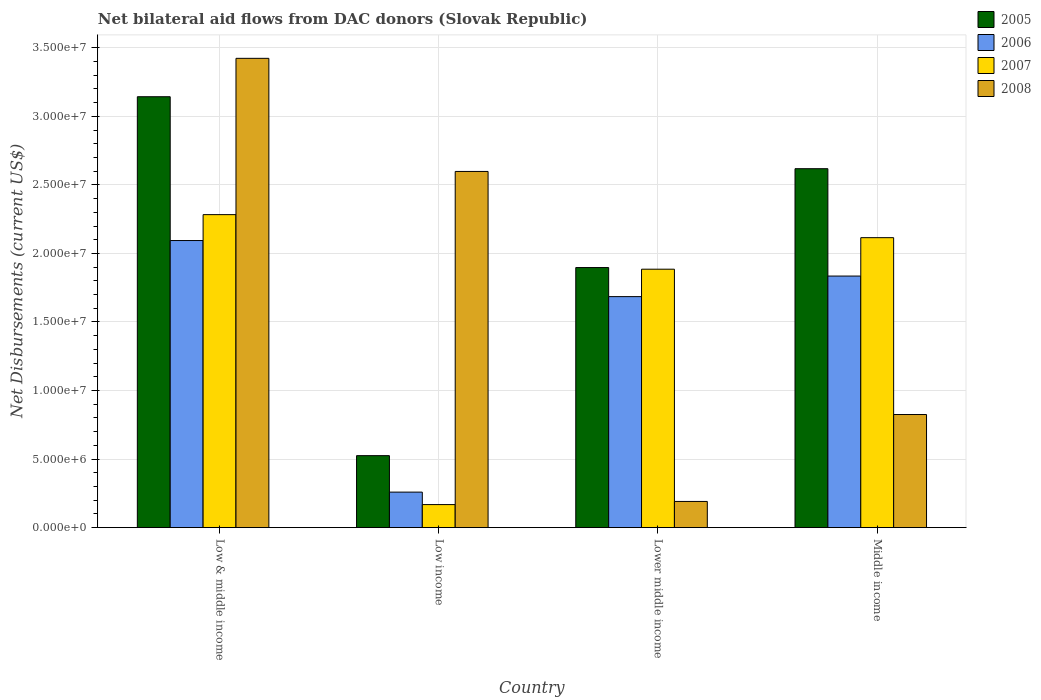How many different coloured bars are there?
Provide a short and direct response. 4. Are the number of bars on each tick of the X-axis equal?
Your answer should be very brief. Yes. How many bars are there on the 1st tick from the right?
Your response must be concise. 4. What is the label of the 3rd group of bars from the left?
Make the answer very short. Lower middle income. What is the net bilateral aid flows in 2007 in Low & middle income?
Give a very brief answer. 2.28e+07. Across all countries, what is the maximum net bilateral aid flows in 2006?
Your answer should be compact. 2.09e+07. Across all countries, what is the minimum net bilateral aid flows in 2006?
Your answer should be compact. 2.59e+06. In which country was the net bilateral aid flows in 2005 maximum?
Make the answer very short. Low & middle income. What is the total net bilateral aid flows in 2005 in the graph?
Offer a terse response. 8.18e+07. What is the difference between the net bilateral aid flows in 2006 in Lower middle income and that in Middle income?
Give a very brief answer. -1.50e+06. What is the difference between the net bilateral aid flows in 2007 in Low & middle income and the net bilateral aid flows in 2005 in Lower middle income?
Give a very brief answer. 3.86e+06. What is the average net bilateral aid flows in 2005 per country?
Offer a very short reply. 2.05e+07. What is the difference between the net bilateral aid flows of/in 2006 and net bilateral aid flows of/in 2005 in Middle income?
Ensure brevity in your answer.  -7.83e+06. In how many countries, is the net bilateral aid flows in 2005 greater than 9000000 US$?
Provide a short and direct response. 3. What is the ratio of the net bilateral aid flows in 2008 in Low income to that in Lower middle income?
Your answer should be compact. 13.6. Is the net bilateral aid flows in 2006 in Low & middle income less than that in Low income?
Offer a terse response. No. What is the difference between the highest and the second highest net bilateral aid flows in 2005?
Provide a short and direct response. 1.25e+07. What is the difference between the highest and the lowest net bilateral aid flows in 2008?
Your answer should be very brief. 3.23e+07. In how many countries, is the net bilateral aid flows in 2006 greater than the average net bilateral aid flows in 2006 taken over all countries?
Your answer should be compact. 3. Is the sum of the net bilateral aid flows in 2005 in Low income and Middle income greater than the maximum net bilateral aid flows in 2006 across all countries?
Give a very brief answer. Yes. Are the values on the major ticks of Y-axis written in scientific E-notation?
Offer a very short reply. Yes. Where does the legend appear in the graph?
Offer a terse response. Top right. How many legend labels are there?
Your response must be concise. 4. What is the title of the graph?
Your response must be concise. Net bilateral aid flows from DAC donors (Slovak Republic). What is the label or title of the X-axis?
Provide a short and direct response. Country. What is the label or title of the Y-axis?
Provide a succinct answer. Net Disbursements (current US$). What is the Net Disbursements (current US$) of 2005 in Low & middle income?
Offer a very short reply. 3.14e+07. What is the Net Disbursements (current US$) in 2006 in Low & middle income?
Provide a succinct answer. 2.09e+07. What is the Net Disbursements (current US$) in 2007 in Low & middle income?
Your answer should be compact. 2.28e+07. What is the Net Disbursements (current US$) of 2008 in Low & middle income?
Offer a terse response. 3.42e+07. What is the Net Disbursements (current US$) in 2005 in Low income?
Your answer should be compact. 5.25e+06. What is the Net Disbursements (current US$) in 2006 in Low income?
Offer a very short reply. 2.59e+06. What is the Net Disbursements (current US$) of 2007 in Low income?
Provide a succinct answer. 1.68e+06. What is the Net Disbursements (current US$) in 2008 in Low income?
Offer a very short reply. 2.60e+07. What is the Net Disbursements (current US$) in 2005 in Lower middle income?
Provide a short and direct response. 1.90e+07. What is the Net Disbursements (current US$) in 2006 in Lower middle income?
Your answer should be very brief. 1.68e+07. What is the Net Disbursements (current US$) in 2007 in Lower middle income?
Make the answer very short. 1.88e+07. What is the Net Disbursements (current US$) of 2008 in Lower middle income?
Ensure brevity in your answer.  1.91e+06. What is the Net Disbursements (current US$) in 2005 in Middle income?
Keep it short and to the point. 2.62e+07. What is the Net Disbursements (current US$) in 2006 in Middle income?
Keep it short and to the point. 1.84e+07. What is the Net Disbursements (current US$) in 2007 in Middle income?
Keep it short and to the point. 2.12e+07. What is the Net Disbursements (current US$) of 2008 in Middle income?
Your answer should be compact. 8.25e+06. Across all countries, what is the maximum Net Disbursements (current US$) of 2005?
Give a very brief answer. 3.14e+07. Across all countries, what is the maximum Net Disbursements (current US$) of 2006?
Your response must be concise. 2.09e+07. Across all countries, what is the maximum Net Disbursements (current US$) of 2007?
Offer a very short reply. 2.28e+07. Across all countries, what is the maximum Net Disbursements (current US$) of 2008?
Ensure brevity in your answer.  3.42e+07. Across all countries, what is the minimum Net Disbursements (current US$) of 2005?
Provide a succinct answer. 5.25e+06. Across all countries, what is the minimum Net Disbursements (current US$) in 2006?
Keep it short and to the point. 2.59e+06. Across all countries, what is the minimum Net Disbursements (current US$) of 2007?
Offer a very short reply. 1.68e+06. Across all countries, what is the minimum Net Disbursements (current US$) in 2008?
Your answer should be compact. 1.91e+06. What is the total Net Disbursements (current US$) in 2005 in the graph?
Offer a very short reply. 8.18e+07. What is the total Net Disbursements (current US$) in 2006 in the graph?
Keep it short and to the point. 5.87e+07. What is the total Net Disbursements (current US$) of 2007 in the graph?
Provide a short and direct response. 6.45e+07. What is the total Net Disbursements (current US$) in 2008 in the graph?
Provide a short and direct response. 7.04e+07. What is the difference between the Net Disbursements (current US$) in 2005 in Low & middle income and that in Low income?
Ensure brevity in your answer.  2.62e+07. What is the difference between the Net Disbursements (current US$) in 2006 in Low & middle income and that in Low income?
Offer a very short reply. 1.84e+07. What is the difference between the Net Disbursements (current US$) of 2007 in Low & middle income and that in Low income?
Ensure brevity in your answer.  2.12e+07. What is the difference between the Net Disbursements (current US$) of 2008 in Low & middle income and that in Low income?
Give a very brief answer. 8.25e+06. What is the difference between the Net Disbursements (current US$) in 2005 in Low & middle income and that in Lower middle income?
Make the answer very short. 1.25e+07. What is the difference between the Net Disbursements (current US$) of 2006 in Low & middle income and that in Lower middle income?
Your answer should be compact. 4.09e+06. What is the difference between the Net Disbursements (current US$) of 2007 in Low & middle income and that in Lower middle income?
Give a very brief answer. 3.98e+06. What is the difference between the Net Disbursements (current US$) of 2008 in Low & middle income and that in Lower middle income?
Keep it short and to the point. 3.23e+07. What is the difference between the Net Disbursements (current US$) of 2005 in Low & middle income and that in Middle income?
Your answer should be compact. 5.25e+06. What is the difference between the Net Disbursements (current US$) of 2006 in Low & middle income and that in Middle income?
Offer a very short reply. 2.59e+06. What is the difference between the Net Disbursements (current US$) in 2007 in Low & middle income and that in Middle income?
Ensure brevity in your answer.  1.68e+06. What is the difference between the Net Disbursements (current US$) of 2008 in Low & middle income and that in Middle income?
Your response must be concise. 2.60e+07. What is the difference between the Net Disbursements (current US$) in 2005 in Low income and that in Lower middle income?
Keep it short and to the point. -1.37e+07. What is the difference between the Net Disbursements (current US$) of 2006 in Low income and that in Lower middle income?
Provide a succinct answer. -1.43e+07. What is the difference between the Net Disbursements (current US$) in 2007 in Low income and that in Lower middle income?
Your answer should be compact. -1.72e+07. What is the difference between the Net Disbursements (current US$) of 2008 in Low income and that in Lower middle income?
Provide a short and direct response. 2.41e+07. What is the difference between the Net Disbursements (current US$) of 2005 in Low income and that in Middle income?
Offer a terse response. -2.09e+07. What is the difference between the Net Disbursements (current US$) in 2006 in Low income and that in Middle income?
Give a very brief answer. -1.58e+07. What is the difference between the Net Disbursements (current US$) of 2007 in Low income and that in Middle income?
Make the answer very short. -1.95e+07. What is the difference between the Net Disbursements (current US$) of 2008 in Low income and that in Middle income?
Ensure brevity in your answer.  1.77e+07. What is the difference between the Net Disbursements (current US$) of 2005 in Lower middle income and that in Middle income?
Offer a terse response. -7.21e+06. What is the difference between the Net Disbursements (current US$) in 2006 in Lower middle income and that in Middle income?
Keep it short and to the point. -1.50e+06. What is the difference between the Net Disbursements (current US$) in 2007 in Lower middle income and that in Middle income?
Your answer should be very brief. -2.30e+06. What is the difference between the Net Disbursements (current US$) in 2008 in Lower middle income and that in Middle income?
Your response must be concise. -6.34e+06. What is the difference between the Net Disbursements (current US$) of 2005 in Low & middle income and the Net Disbursements (current US$) of 2006 in Low income?
Make the answer very short. 2.88e+07. What is the difference between the Net Disbursements (current US$) in 2005 in Low & middle income and the Net Disbursements (current US$) in 2007 in Low income?
Make the answer very short. 2.98e+07. What is the difference between the Net Disbursements (current US$) of 2005 in Low & middle income and the Net Disbursements (current US$) of 2008 in Low income?
Provide a succinct answer. 5.45e+06. What is the difference between the Net Disbursements (current US$) in 2006 in Low & middle income and the Net Disbursements (current US$) in 2007 in Low income?
Your answer should be very brief. 1.93e+07. What is the difference between the Net Disbursements (current US$) of 2006 in Low & middle income and the Net Disbursements (current US$) of 2008 in Low income?
Give a very brief answer. -5.04e+06. What is the difference between the Net Disbursements (current US$) in 2007 in Low & middle income and the Net Disbursements (current US$) in 2008 in Low income?
Your answer should be very brief. -3.15e+06. What is the difference between the Net Disbursements (current US$) of 2005 in Low & middle income and the Net Disbursements (current US$) of 2006 in Lower middle income?
Your response must be concise. 1.46e+07. What is the difference between the Net Disbursements (current US$) of 2005 in Low & middle income and the Net Disbursements (current US$) of 2007 in Lower middle income?
Offer a very short reply. 1.26e+07. What is the difference between the Net Disbursements (current US$) of 2005 in Low & middle income and the Net Disbursements (current US$) of 2008 in Lower middle income?
Ensure brevity in your answer.  2.95e+07. What is the difference between the Net Disbursements (current US$) in 2006 in Low & middle income and the Net Disbursements (current US$) in 2007 in Lower middle income?
Provide a succinct answer. 2.09e+06. What is the difference between the Net Disbursements (current US$) in 2006 in Low & middle income and the Net Disbursements (current US$) in 2008 in Lower middle income?
Ensure brevity in your answer.  1.90e+07. What is the difference between the Net Disbursements (current US$) in 2007 in Low & middle income and the Net Disbursements (current US$) in 2008 in Lower middle income?
Give a very brief answer. 2.09e+07. What is the difference between the Net Disbursements (current US$) of 2005 in Low & middle income and the Net Disbursements (current US$) of 2006 in Middle income?
Your answer should be very brief. 1.31e+07. What is the difference between the Net Disbursements (current US$) in 2005 in Low & middle income and the Net Disbursements (current US$) in 2007 in Middle income?
Your response must be concise. 1.03e+07. What is the difference between the Net Disbursements (current US$) of 2005 in Low & middle income and the Net Disbursements (current US$) of 2008 in Middle income?
Provide a succinct answer. 2.32e+07. What is the difference between the Net Disbursements (current US$) of 2006 in Low & middle income and the Net Disbursements (current US$) of 2008 in Middle income?
Keep it short and to the point. 1.27e+07. What is the difference between the Net Disbursements (current US$) of 2007 in Low & middle income and the Net Disbursements (current US$) of 2008 in Middle income?
Provide a short and direct response. 1.46e+07. What is the difference between the Net Disbursements (current US$) in 2005 in Low income and the Net Disbursements (current US$) in 2006 in Lower middle income?
Keep it short and to the point. -1.16e+07. What is the difference between the Net Disbursements (current US$) in 2005 in Low income and the Net Disbursements (current US$) in 2007 in Lower middle income?
Your response must be concise. -1.36e+07. What is the difference between the Net Disbursements (current US$) in 2005 in Low income and the Net Disbursements (current US$) in 2008 in Lower middle income?
Your response must be concise. 3.34e+06. What is the difference between the Net Disbursements (current US$) of 2006 in Low income and the Net Disbursements (current US$) of 2007 in Lower middle income?
Offer a very short reply. -1.63e+07. What is the difference between the Net Disbursements (current US$) of 2006 in Low income and the Net Disbursements (current US$) of 2008 in Lower middle income?
Provide a short and direct response. 6.80e+05. What is the difference between the Net Disbursements (current US$) in 2005 in Low income and the Net Disbursements (current US$) in 2006 in Middle income?
Give a very brief answer. -1.31e+07. What is the difference between the Net Disbursements (current US$) of 2005 in Low income and the Net Disbursements (current US$) of 2007 in Middle income?
Your answer should be very brief. -1.59e+07. What is the difference between the Net Disbursements (current US$) in 2005 in Low income and the Net Disbursements (current US$) in 2008 in Middle income?
Give a very brief answer. -3.00e+06. What is the difference between the Net Disbursements (current US$) in 2006 in Low income and the Net Disbursements (current US$) in 2007 in Middle income?
Provide a succinct answer. -1.86e+07. What is the difference between the Net Disbursements (current US$) in 2006 in Low income and the Net Disbursements (current US$) in 2008 in Middle income?
Make the answer very short. -5.66e+06. What is the difference between the Net Disbursements (current US$) of 2007 in Low income and the Net Disbursements (current US$) of 2008 in Middle income?
Your answer should be very brief. -6.57e+06. What is the difference between the Net Disbursements (current US$) in 2005 in Lower middle income and the Net Disbursements (current US$) in 2006 in Middle income?
Ensure brevity in your answer.  6.20e+05. What is the difference between the Net Disbursements (current US$) in 2005 in Lower middle income and the Net Disbursements (current US$) in 2007 in Middle income?
Give a very brief answer. -2.18e+06. What is the difference between the Net Disbursements (current US$) of 2005 in Lower middle income and the Net Disbursements (current US$) of 2008 in Middle income?
Make the answer very short. 1.07e+07. What is the difference between the Net Disbursements (current US$) of 2006 in Lower middle income and the Net Disbursements (current US$) of 2007 in Middle income?
Make the answer very short. -4.30e+06. What is the difference between the Net Disbursements (current US$) in 2006 in Lower middle income and the Net Disbursements (current US$) in 2008 in Middle income?
Make the answer very short. 8.60e+06. What is the difference between the Net Disbursements (current US$) of 2007 in Lower middle income and the Net Disbursements (current US$) of 2008 in Middle income?
Offer a very short reply. 1.06e+07. What is the average Net Disbursements (current US$) of 2005 per country?
Provide a succinct answer. 2.05e+07. What is the average Net Disbursements (current US$) of 2006 per country?
Your answer should be compact. 1.47e+07. What is the average Net Disbursements (current US$) of 2007 per country?
Your answer should be compact. 1.61e+07. What is the average Net Disbursements (current US$) in 2008 per country?
Offer a terse response. 1.76e+07. What is the difference between the Net Disbursements (current US$) of 2005 and Net Disbursements (current US$) of 2006 in Low & middle income?
Offer a terse response. 1.05e+07. What is the difference between the Net Disbursements (current US$) of 2005 and Net Disbursements (current US$) of 2007 in Low & middle income?
Ensure brevity in your answer.  8.60e+06. What is the difference between the Net Disbursements (current US$) of 2005 and Net Disbursements (current US$) of 2008 in Low & middle income?
Your response must be concise. -2.80e+06. What is the difference between the Net Disbursements (current US$) of 2006 and Net Disbursements (current US$) of 2007 in Low & middle income?
Provide a short and direct response. -1.89e+06. What is the difference between the Net Disbursements (current US$) in 2006 and Net Disbursements (current US$) in 2008 in Low & middle income?
Make the answer very short. -1.33e+07. What is the difference between the Net Disbursements (current US$) in 2007 and Net Disbursements (current US$) in 2008 in Low & middle income?
Your answer should be very brief. -1.14e+07. What is the difference between the Net Disbursements (current US$) in 2005 and Net Disbursements (current US$) in 2006 in Low income?
Ensure brevity in your answer.  2.66e+06. What is the difference between the Net Disbursements (current US$) of 2005 and Net Disbursements (current US$) of 2007 in Low income?
Your answer should be compact. 3.57e+06. What is the difference between the Net Disbursements (current US$) in 2005 and Net Disbursements (current US$) in 2008 in Low income?
Ensure brevity in your answer.  -2.07e+07. What is the difference between the Net Disbursements (current US$) of 2006 and Net Disbursements (current US$) of 2007 in Low income?
Ensure brevity in your answer.  9.10e+05. What is the difference between the Net Disbursements (current US$) of 2006 and Net Disbursements (current US$) of 2008 in Low income?
Provide a succinct answer. -2.34e+07. What is the difference between the Net Disbursements (current US$) of 2007 and Net Disbursements (current US$) of 2008 in Low income?
Offer a very short reply. -2.43e+07. What is the difference between the Net Disbursements (current US$) of 2005 and Net Disbursements (current US$) of 2006 in Lower middle income?
Your answer should be compact. 2.12e+06. What is the difference between the Net Disbursements (current US$) of 2005 and Net Disbursements (current US$) of 2008 in Lower middle income?
Your response must be concise. 1.71e+07. What is the difference between the Net Disbursements (current US$) in 2006 and Net Disbursements (current US$) in 2008 in Lower middle income?
Keep it short and to the point. 1.49e+07. What is the difference between the Net Disbursements (current US$) of 2007 and Net Disbursements (current US$) of 2008 in Lower middle income?
Your answer should be compact. 1.69e+07. What is the difference between the Net Disbursements (current US$) of 2005 and Net Disbursements (current US$) of 2006 in Middle income?
Offer a terse response. 7.83e+06. What is the difference between the Net Disbursements (current US$) in 2005 and Net Disbursements (current US$) in 2007 in Middle income?
Offer a very short reply. 5.03e+06. What is the difference between the Net Disbursements (current US$) in 2005 and Net Disbursements (current US$) in 2008 in Middle income?
Your answer should be compact. 1.79e+07. What is the difference between the Net Disbursements (current US$) of 2006 and Net Disbursements (current US$) of 2007 in Middle income?
Offer a terse response. -2.80e+06. What is the difference between the Net Disbursements (current US$) of 2006 and Net Disbursements (current US$) of 2008 in Middle income?
Make the answer very short. 1.01e+07. What is the difference between the Net Disbursements (current US$) in 2007 and Net Disbursements (current US$) in 2008 in Middle income?
Make the answer very short. 1.29e+07. What is the ratio of the Net Disbursements (current US$) in 2005 in Low & middle income to that in Low income?
Your answer should be compact. 5.99. What is the ratio of the Net Disbursements (current US$) of 2006 in Low & middle income to that in Low income?
Keep it short and to the point. 8.08. What is the ratio of the Net Disbursements (current US$) in 2007 in Low & middle income to that in Low income?
Ensure brevity in your answer.  13.59. What is the ratio of the Net Disbursements (current US$) of 2008 in Low & middle income to that in Low income?
Give a very brief answer. 1.32. What is the ratio of the Net Disbursements (current US$) in 2005 in Low & middle income to that in Lower middle income?
Offer a very short reply. 1.66. What is the ratio of the Net Disbursements (current US$) in 2006 in Low & middle income to that in Lower middle income?
Your answer should be very brief. 1.24. What is the ratio of the Net Disbursements (current US$) in 2007 in Low & middle income to that in Lower middle income?
Your response must be concise. 1.21. What is the ratio of the Net Disbursements (current US$) of 2008 in Low & middle income to that in Lower middle income?
Your answer should be very brief. 17.92. What is the ratio of the Net Disbursements (current US$) in 2005 in Low & middle income to that in Middle income?
Make the answer very short. 1.2. What is the ratio of the Net Disbursements (current US$) of 2006 in Low & middle income to that in Middle income?
Give a very brief answer. 1.14. What is the ratio of the Net Disbursements (current US$) of 2007 in Low & middle income to that in Middle income?
Your answer should be compact. 1.08. What is the ratio of the Net Disbursements (current US$) of 2008 in Low & middle income to that in Middle income?
Provide a short and direct response. 4.15. What is the ratio of the Net Disbursements (current US$) of 2005 in Low income to that in Lower middle income?
Keep it short and to the point. 0.28. What is the ratio of the Net Disbursements (current US$) of 2006 in Low income to that in Lower middle income?
Give a very brief answer. 0.15. What is the ratio of the Net Disbursements (current US$) in 2007 in Low income to that in Lower middle income?
Your answer should be compact. 0.09. What is the ratio of the Net Disbursements (current US$) of 2008 in Low income to that in Lower middle income?
Your answer should be very brief. 13.6. What is the ratio of the Net Disbursements (current US$) in 2005 in Low income to that in Middle income?
Offer a very short reply. 0.2. What is the ratio of the Net Disbursements (current US$) of 2006 in Low income to that in Middle income?
Your answer should be very brief. 0.14. What is the ratio of the Net Disbursements (current US$) of 2007 in Low income to that in Middle income?
Make the answer very short. 0.08. What is the ratio of the Net Disbursements (current US$) of 2008 in Low income to that in Middle income?
Give a very brief answer. 3.15. What is the ratio of the Net Disbursements (current US$) of 2005 in Lower middle income to that in Middle income?
Your answer should be very brief. 0.72. What is the ratio of the Net Disbursements (current US$) in 2006 in Lower middle income to that in Middle income?
Make the answer very short. 0.92. What is the ratio of the Net Disbursements (current US$) of 2007 in Lower middle income to that in Middle income?
Ensure brevity in your answer.  0.89. What is the ratio of the Net Disbursements (current US$) of 2008 in Lower middle income to that in Middle income?
Offer a terse response. 0.23. What is the difference between the highest and the second highest Net Disbursements (current US$) of 2005?
Offer a terse response. 5.25e+06. What is the difference between the highest and the second highest Net Disbursements (current US$) of 2006?
Give a very brief answer. 2.59e+06. What is the difference between the highest and the second highest Net Disbursements (current US$) in 2007?
Your response must be concise. 1.68e+06. What is the difference between the highest and the second highest Net Disbursements (current US$) of 2008?
Offer a very short reply. 8.25e+06. What is the difference between the highest and the lowest Net Disbursements (current US$) of 2005?
Your answer should be compact. 2.62e+07. What is the difference between the highest and the lowest Net Disbursements (current US$) of 2006?
Your answer should be very brief. 1.84e+07. What is the difference between the highest and the lowest Net Disbursements (current US$) in 2007?
Provide a short and direct response. 2.12e+07. What is the difference between the highest and the lowest Net Disbursements (current US$) in 2008?
Offer a very short reply. 3.23e+07. 